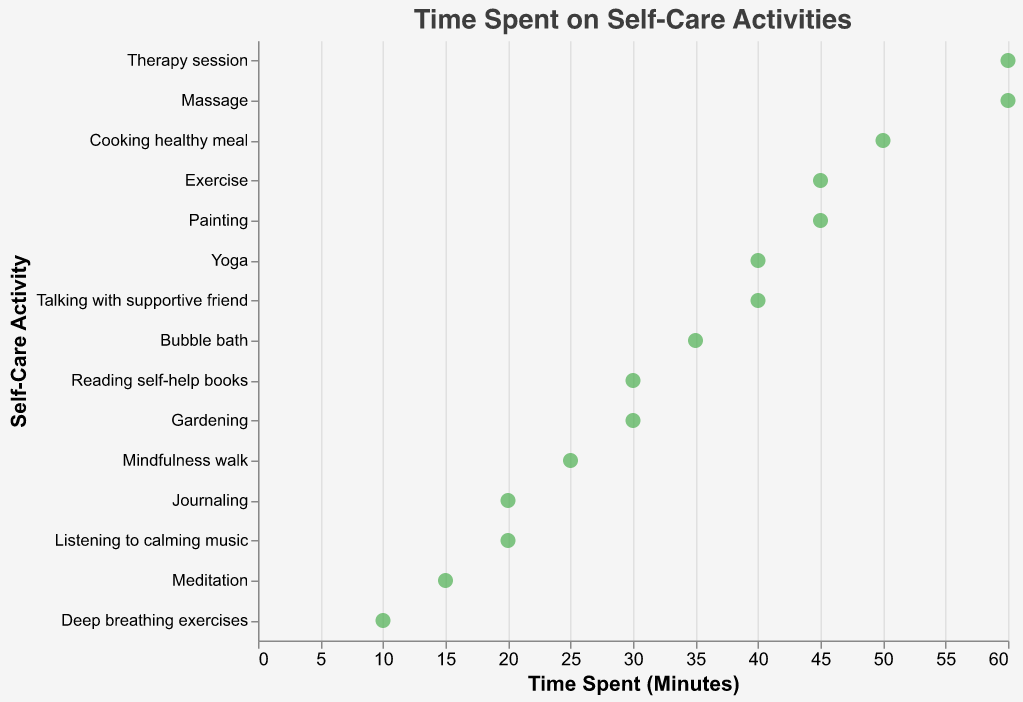What is the title of the plot? The title is typically displayed at the top of the plot. It is written in a larger and bolder font compared to other text elements to easily identify the main topic of the figure. The title of the plot is "Time Spent on Self-Care Activities"
Answer: Time Spent on Self-Care Activities Which activity has the highest time spent? By looking at the y-axis and identifying the dot that is positioned farthest to the right on the x-axis, we determine that the activity with the highest time spent is "Therapy session" and "Massage" with 60 minutes each
Answer: Therapy session, Massage What activities have a time spent of 45 minutes? On the x-axis, locate the marks that align with 45 minutes and then trace these dots to the y-axis to identify the corresponding activities. The activities are "Exercise" and "Painting"
Answer: Exercise, Painting What is the range of time spent on self-care activities? The range is determined by the difference between the maximum and minimum values on the x-axis. The minimum time spent is 10 minutes (Deep breathing exercises), and the maximum is 60 minutes (Therapy session and Massage), so the range is 60 - 10 = 50 minutes
Answer: 50 minutes Which activities have the same amount of time spent? Look for multiple data points aligned vertically on the same x-axis value. Both "Yoga" and "Talking with supportive friend" are at 40 minutes, and "Massage" and "Therapy session" are at 60 minutes
Answer: Yoga and Talking with supportive friend; Massage and Therapy session What is the median time spent on self-care activities? First, list the time spent in ascending order: [10, 15, 20, 20, 25, 30, 30, 35, 40, 40, 45, 45, 50, 60, 60]. Since there are 15 data points, the median is the value at the 8th position, which is 35 minutes
Answer: 35 minutes Which self-care activity requires the least time? Identify the data point that is positioned farthest to the left on the x-axis. This point corresponds to "Deep breathing exercises" with 10 minutes
Answer: Deep breathing exercises What is the total time spent on all self-care activities? Sum up all the values for each activity: 15 + 20 + 45 + 60 + 30 + 40 + 25 + 35 + 50 + 40 + 30 + 20 + 45 + 10 + 60 = 525 minutes
Answer: 525 minutes Are there more activities with less than 30 minutes or 30 minutes and above? Count the number of activities with less than 30 minutes: 5 activities (Meditation, Journaling, Mindfulness walk, Listening to calming music, Deep breathing exercises). Count the number with 30 minutes and above: 10 activities. There are more activities with 30 minutes and above
Answer: 30 minutes and above Which activity is closest to the median time spent? The median time spent is 35 minutes. Identify the activity associated with 35 minutes which matches the median value. The closest activity is "Bubble bath"
Answer: Bubble bath 